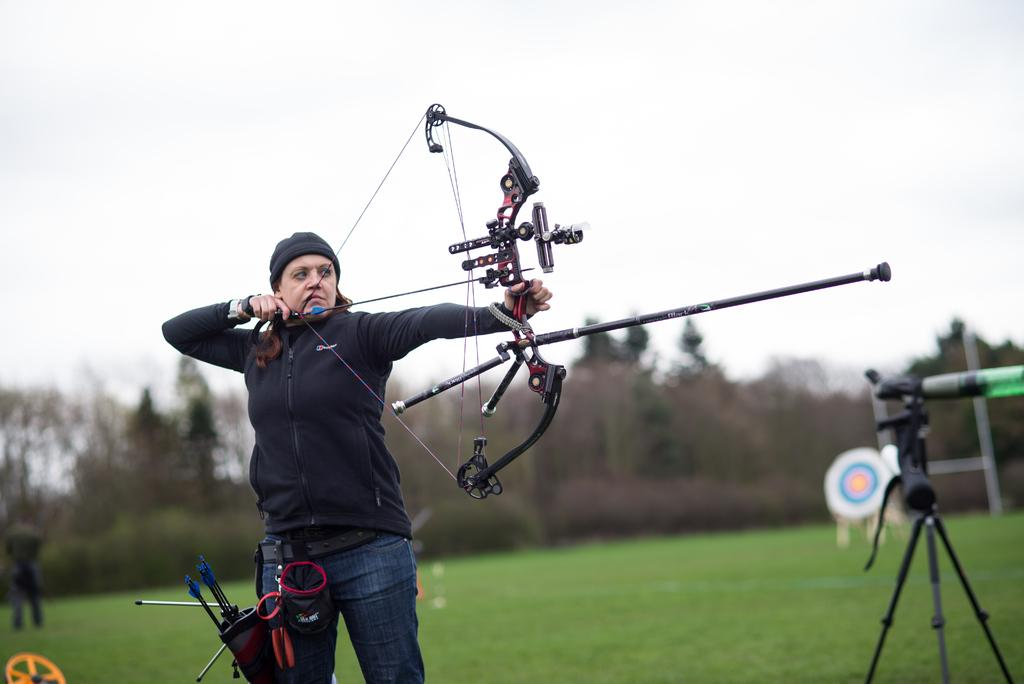What is the main subject of the image? There is a woman in the image. What is the woman holding in her hand? The woman is holding a bow in her hand. What is the woman's posture in the image? The woman is standing in the image. Can you describe the background of the image? There is a person, a tripod stand, an archery target, trees, and the sky visible in the background of the image. What type of kettle can be seen in the image? There is no kettle present in the image. Can you recite a verse from the image? There is no text or verse present in the image. 